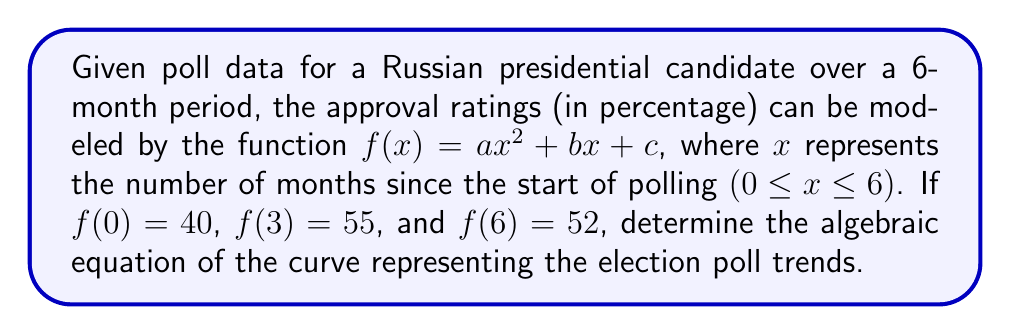Help me with this question. Let's approach this step-by-step:

1) We know that $f(x) = ax^2 + bx + c$. We need to find the values of $a$, $b$, and $c$.

2) Given information:
   $f(0) = 40$
   $f(3) = 55$
   $f(6) = 52$

3) Let's use these points to create a system of equations:

   $f(0) = a(0)^2 + b(0) + c = 40$
   $f(3) = a(3)^2 + b(3) + c = 55$
   $f(6) = a(6)^2 + b(6) + c = 52$

4) Simplify:

   $c = 40$ (from the first equation)
   $9a + 3b + 40 = 55$
   $36a + 6b + 40 = 52$

5) Substitute $c = 40$ into the other equations:

   $9a + 3b = 15$
   $36a + 6b = 12$

6) Multiply the first equation by 2 and subtract from the second:

   $18a + 6b = 30$
   $36a + 6b = 12$
   ----------------
   $-18a = -18$

7) Solve for $a$:

   $a = 1$

8) Substitute $a = 1$ into $9a + 3b = 15$:

   $9 + 3b = 15$
   $3b = 6$
   $b = 2$

9) We now have $a = 1$, $b = 2$, and $c = 40$

Therefore, the algebraic equation of the curve is:

$$f(x) = x^2 + 2x + 40$$
Answer: $f(x) = x^2 + 2x + 40$ 